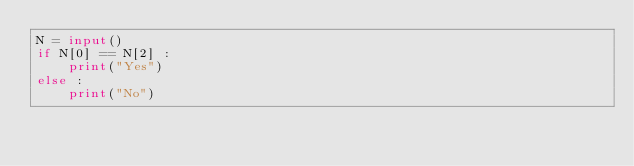<code> <loc_0><loc_0><loc_500><loc_500><_Python_>N = input()
if N[0] == N[2] :
    print("Yes")
else :
    print("No")
    
    
    </code> 